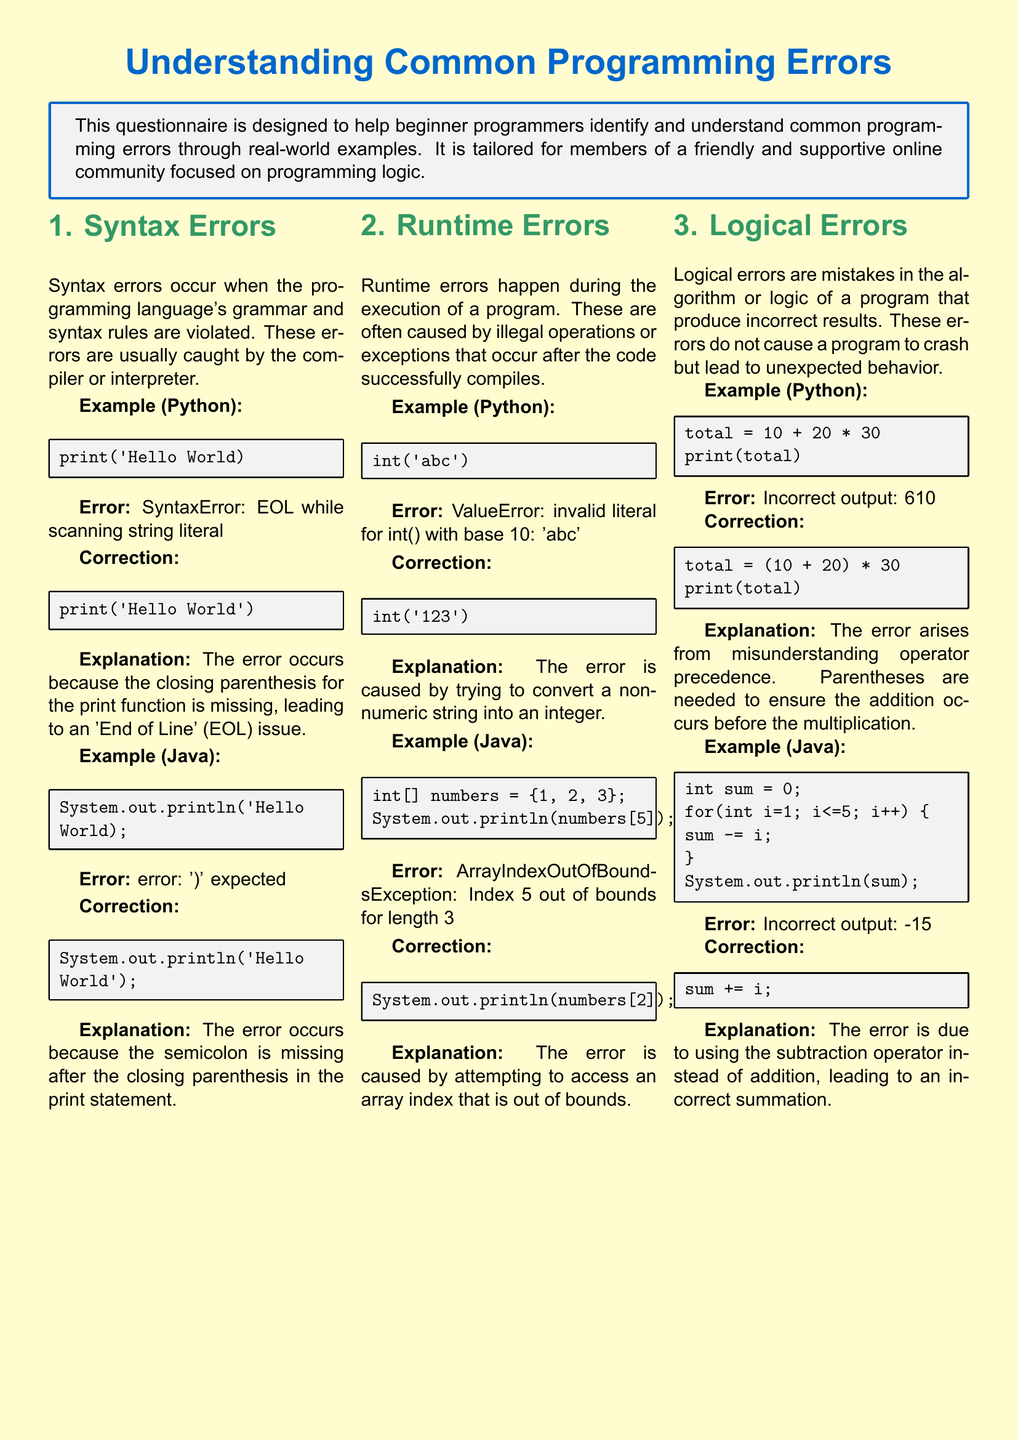what is the main purpose of the questionnaire? The questionnaire is designed to help beginner programmers identify and understand common programming errors through real-world examples.
Answer: identify and understand common programming errors how many sections are in the document? The document contains three sections: Syntax Errors, Runtime Errors, and Logical Errors.
Answer: three what type of error is caused by a missing parenthesis in Python? Syntax errors occur when the programming language's grammar and syntax rules are violated.
Answer: Syntax errors what is the output of the Python example that involves adding and multiplying? The error arises from misunderstanding operator precedence, leading to an incorrect output.
Answer: Incorrect output: 610 what kind of error is indicated by 'Index out of bounds'? Runtime errors happen during the execution of a program and are often caused by illegal operations.
Answer: Runtime errors what correction should be made for the Java example that has 'Hello World' print statement? The correction involves adding a semicolon after the closing parenthesis in the print statement.
Answer: add a semicolon what explanation is given for the logical error in the Java loop example? The error is due to using the subtraction operator instead of addition, leading to an incorrect summation.
Answer: using the subtraction operator instead of addition what is the error type for 'invalid literal for int() with base 10'? This error is categorized as a runtime error that occurs during the execution of a program.
Answer: runtime error 